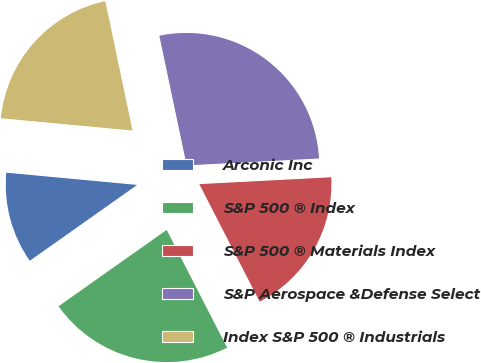Convert chart to OTSL. <chart><loc_0><loc_0><loc_500><loc_500><pie_chart><fcel>Arconic Inc<fcel>S&P 500 ® Index<fcel>S&P 500 ® Materials Index<fcel>S&P Aerospace &Defense Select<fcel>Index S&P 500 ® Industrials<nl><fcel>11.27%<fcel>22.76%<fcel>18.28%<fcel>27.48%<fcel>20.21%<nl></chart> 